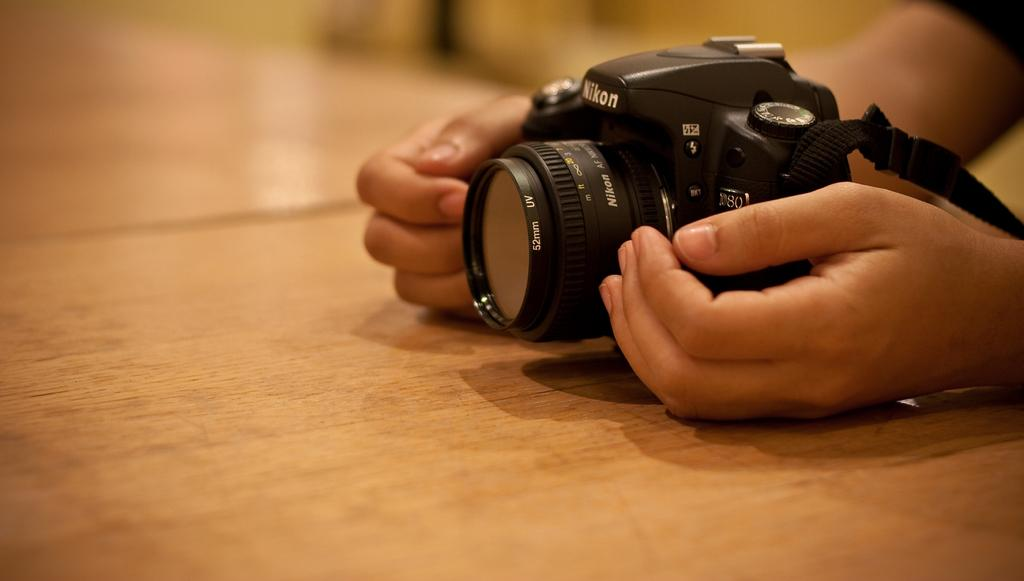What object is the main focus of the image? There is a camera in the image. Where is the camera located? The camera is on a table. Can you describe any part of the person in the image? There is a person's hand visible in the image, and the person is wearing a t-shirt. Where is the ball located in the image? There is no ball present in the image. What type of park can be seen in the background of the image? There is no park visible in the image; it only shows a camera on a table. 